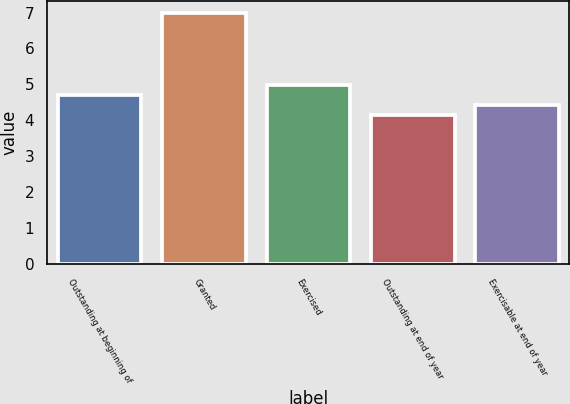Convert chart. <chart><loc_0><loc_0><loc_500><loc_500><bar_chart><fcel>Outstanding at beginning of<fcel>Granted<fcel>Exercised<fcel>Outstanding at end of year<fcel>Exercisable at end of year<nl><fcel>4.71<fcel>6.98<fcel>4.99<fcel>4.15<fcel>4.43<nl></chart> 